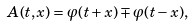Convert formula to latex. <formula><loc_0><loc_0><loc_500><loc_500>A ( t , x ) = \varphi ( t + x ) \mp \varphi ( t - x ) ,</formula> 